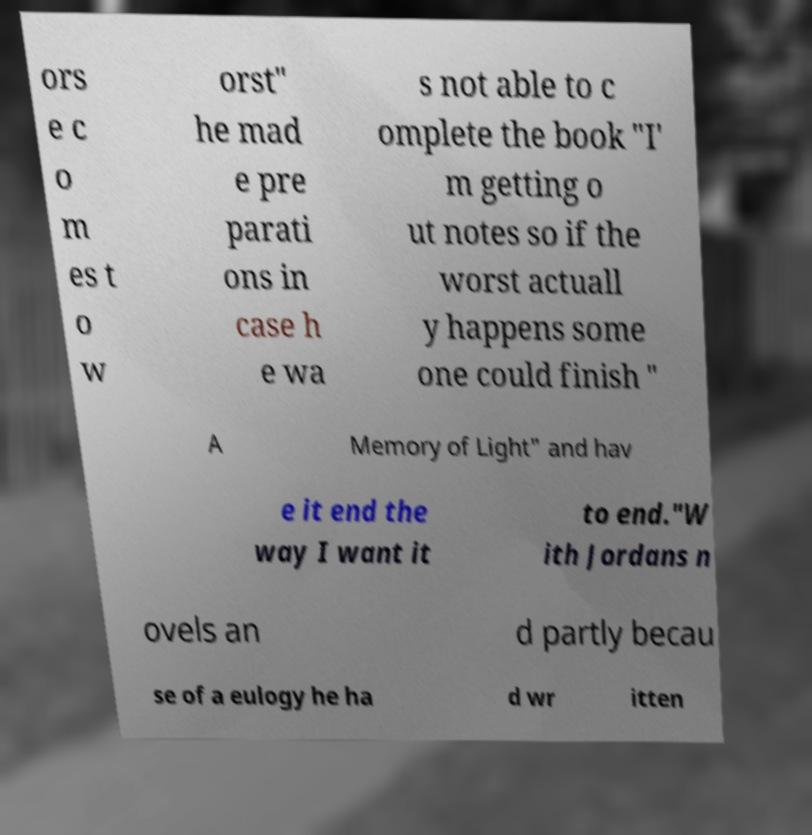Can you read and provide the text displayed in the image?This photo seems to have some interesting text. Can you extract and type it out for me? ors e c o m es t o w orst" he mad e pre parati ons in case h e wa s not able to c omplete the book "I' m getting o ut notes so if the worst actuall y happens some one could finish " A Memory of Light" and hav e it end the way I want it to end."W ith Jordans n ovels an d partly becau se of a eulogy he ha d wr itten 